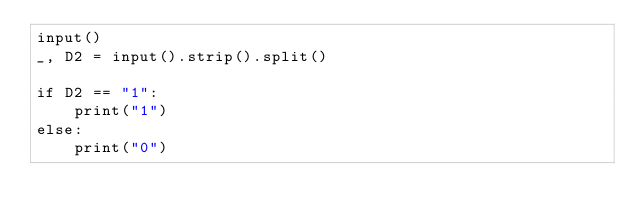<code> <loc_0><loc_0><loc_500><loc_500><_Python_>input()
_, D2 = input().strip().split()

if D2 == "1":
    print("1")
else:
    print("0")</code> 